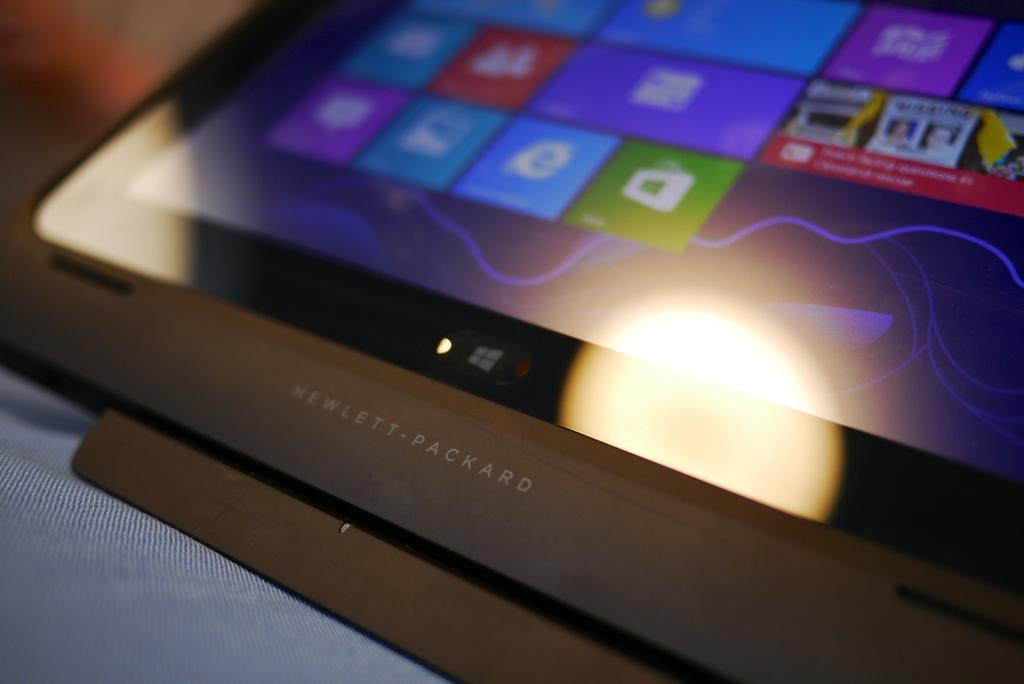What is the main subject of the image? The main subject of the image is a tab. What health benefits does the tab provide in the image? The image does not depict any health benefits associated with the tab, as it is not a living organism or a health-related item. 